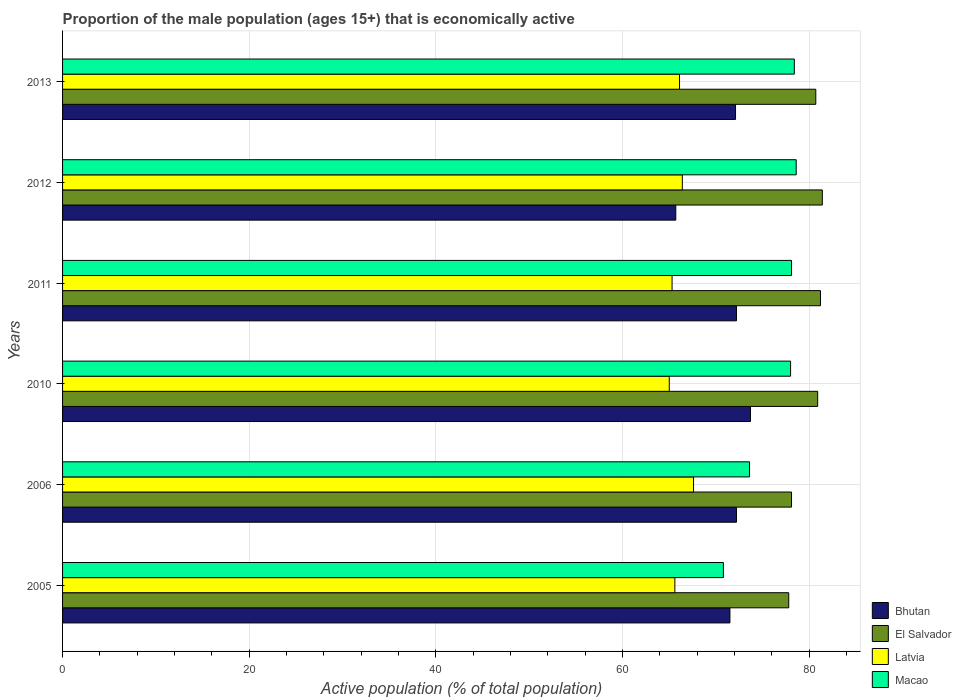How many different coloured bars are there?
Your answer should be very brief. 4. How many bars are there on the 2nd tick from the top?
Give a very brief answer. 4. How many bars are there on the 4th tick from the bottom?
Ensure brevity in your answer.  4. What is the label of the 6th group of bars from the top?
Give a very brief answer. 2005. What is the proportion of the male population that is economically active in Macao in 2012?
Your response must be concise. 78.6. Across all years, what is the maximum proportion of the male population that is economically active in Bhutan?
Provide a succinct answer. 73.7. Across all years, what is the minimum proportion of the male population that is economically active in Latvia?
Ensure brevity in your answer.  65. What is the total proportion of the male population that is economically active in Bhutan in the graph?
Ensure brevity in your answer.  427.4. What is the difference between the proportion of the male population that is economically active in El Salvador in 2010 and that in 2011?
Make the answer very short. -0.3. What is the difference between the proportion of the male population that is economically active in Latvia in 2010 and the proportion of the male population that is economically active in Macao in 2013?
Offer a terse response. -13.4. What is the average proportion of the male population that is economically active in Macao per year?
Make the answer very short. 76.25. In the year 2010, what is the difference between the proportion of the male population that is economically active in Bhutan and proportion of the male population that is economically active in Latvia?
Your answer should be very brief. 8.7. In how many years, is the proportion of the male population that is economically active in El Salvador greater than 24 %?
Make the answer very short. 6. What is the ratio of the proportion of the male population that is economically active in Macao in 2005 to that in 2011?
Your answer should be very brief. 0.91. Is the difference between the proportion of the male population that is economically active in Bhutan in 2006 and 2012 greater than the difference between the proportion of the male population that is economically active in Latvia in 2006 and 2012?
Your answer should be very brief. Yes. What is the difference between the highest and the second highest proportion of the male population that is economically active in Macao?
Ensure brevity in your answer.  0.2. What is the difference between the highest and the lowest proportion of the male population that is economically active in El Salvador?
Make the answer very short. 3.6. Is it the case that in every year, the sum of the proportion of the male population that is economically active in El Salvador and proportion of the male population that is economically active in Latvia is greater than the sum of proportion of the male population that is economically active in Macao and proportion of the male population that is economically active in Bhutan?
Your answer should be very brief. Yes. What does the 1st bar from the top in 2010 represents?
Provide a short and direct response. Macao. What does the 1st bar from the bottom in 2006 represents?
Keep it short and to the point. Bhutan. Are all the bars in the graph horizontal?
Provide a succinct answer. Yes. What is the difference between two consecutive major ticks on the X-axis?
Your answer should be very brief. 20. Are the values on the major ticks of X-axis written in scientific E-notation?
Your answer should be very brief. No. Does the graph contain any zero values?
Offer a very short reply. No. How are the legend labels stacked?
Your answer should be compact. Vertical. What is the title of the graph?
Ensure brevity in your answer.  Proportion of the male population (ages 15+) that is economically active. Does "Isle of Man" appear as one of the legend labels in the graph?
Provide a succinct answer. No. What is the label or title of the X-axis?
Keep it short and to the point. Active population (% of total population). What is the label or title of the Y-axis?
Give a very brief answer. Years. What is the Active population (% of total population) in Bhutan in 2005?
Ensure brevity in your answer.  71.5. What is the Active population (% of total population) of El Salvador in 2005?
Make the answer very short. 77.8. What is the Active population (% of total population) of Latvia in 2005?
Offer a terse response. 65.6. What is the Active population (% of total population) of Macao in 2005?
Offer a terse response. 70.8. What is the Active population (% of total population) of Bhutan in 2006?
Offer a terse response. 72.2. What is the Active population (% of total population) of El Salvador in 2006?
Offer a very short reply. 78.1. What is the Active population (% of total population) of Latvia in 2006?
Offer a terse response. 67.6. What is the Active population (% of total population) in Macao in 2006?
Give a very brief answer. 73.6. What is the Active population (% of total population) of Bhutan in 2010?
Provide a succinct answer. 73.7. What is the Active population (% of total population) in El Salvador in 2010?
Give a very brief answer. 80.9. What is the Active population (% of total population) of Latvia in 2010?
Your answer should be very brief. 65. What is the Active population (% of total population) of Bhutan in 2011?
Give a very brief answer. 72.2. What is the Active population (% of total population) of El Salvador in 2011?
Your answer should be very brief. 81.2. What is the Active population (% of total population) of Latvia in 2011?
Keep it short and to the point. 65.3. What is the Active population (% of total population) in Macao in 2011?
Provide a short and direct response. 78.1. What is the Active population (% of total population) of Bhutan in 2012?
Offer a terse response. 65.7. What is the Active population (% of total population) in El Salvador in 2012?
Provide a short and direct response. 81.4. What is the Active population (% of total population) in Latvia in 2012?
Your answer should be compact. 66.4. What is the Active population (% of total population) in Macao in 2012?
Provide a short and direct response. 78.6. What is the Active population (% of total population) in Bhutan in 2013?
Keep it short and to the point. 72.1. What is the Active population (% of total population) of El Salvador in 2013?
Provide a short and direct response. 80.7. What is the Active population (% of total population) of Latvia in 2013?
Keep it short and to the point. 66.1. What is the Active population (% of total population) of Macao in 2013?
Give a very brief answer. 78.4. Across all years, what is the maximum Active population (% of total population) in Bhutan?
Keep it short and to the point. 73.7. Across all years, what is the maximum Active population (% of total population) of El Salvador?
Provide a short and direct response. 81.4. Across all years, what is the maximum Active population (% of total population) of Latvia?
Your answer should be compact. 67.6. Across all years, what is the maximum Active population (% of total population) of Macao?
Make the answer very short. 78.6. Across all years, what is the minimum Active population (% of total population) in Bhutan?
Offer a very short reply. 65.7. Across all years, what is the minimum Active population (% of total population) in El Salvador?
Offer a terse response. 77.8. Across all years, what is the minimum Active population (% of total population) in Latvia?
Provide a succinct answer. 65. Across all years, what is the minimum Active population (% of total population) of Macao?
Make the answer very short. 70.8. What is the total Active population (% of total population) in Bhutan in the graph?
Keep it short and to the point. 427.4. What is the total Active population (% of total population) of El Salvador in the graph?
Provide a short and direct response. 480.1. What is the total Active population (% of total population) of Latvia in the graph?
Your answer should be very brief. 396. What is the total Active population (% of total population) in Macao in the graph?
Provide a succinct answer. 457.5. What is the difference between the Active population (% of total population) of Latvia in 2005 and that in 2011?
Offer a very short reply. 0.3. What is the difference between the Active population (% of total population) of Macao in 2005 and that in 2011?
Your answer should be very brief. -7.3. What is the difference between the Active population (% of total population) in Bhutan in 2005 and that in 2013?
Offer a very short reply. -0.6. What is the difference between the Active population (% of total population) in Macao in 2005 and that in 2013?
Your response must be concise. -7.6. What is the difference between the Active population (% of total population) in El Salvador in 2006 and that in 2010?
Your response must be concise. -2.8. What is the difference between the Active population (% of total population) in Latvia in 2006 and that in 2010?
Give a very brief answer. 2.6. What is the difference between the Active population (% of total population) in Macao in 2006 and that in 2010?
Provide a short and direct response. -4.4. What is the difference between the Active population (% of total population) in Latvia in 2006 and that in 2011?
Provide a short and direct response. 2.3. What is the difference between the Active population (% of total population) in Bhutan in 2006 and that in 2012?
Your answer should be compact. 6.5. What is the difference between the Active population (% of total population) in El Salvador in 2006 and that in 2012?
Provide a succinct answer. -3.3. What is the difference between the Active population (% of total population) in Latvia in 2006 and that in 2012?
Keep it short and to the point. 1.2. What is the difference between the Active population (% of total population) in Bhutan in 2006 and that in 2013?
Offer a terse response. 0.1. What is the difference between the Active population (% of total population) in El Salvador in 2006 and that in 2013?
Your answer should be very brief. -2.6. What is the difference between the Active population (% of total population) in Latvia in 2006 and that in 2013?
Keep it short and to the point. 1.5. What is the difference between the Active population (% of total population) of Macao in 2006 and that in 2013?
Provide a succinct answer. -4.8. What is the difference between the Active population (% of total population) in Bhutan in 2010 and that in 2011?
Provide a short and direct response. 1.5. What is the difference between the Active population (% of total population) in El Salvador in 2010 and that in 2011?
Give a very brief answer. -0.3. What is the difference between the Active population (% of total population) in Latvia in 2010 and that in 2011?
Keep it short and to the point. -0.3. What is the difference between the Active population (% of total population) in Bhutan in 2010 and that in 2012?
Make the answer very short. 8. What is the difference between the Active population (% of total population) in El Salvador in 2010 and that in 2012?
Make the answer very short. -0.5. What is the difference between the Active population (% of total population) of Latvia in 2010 and that in 2012?
Your response must be concise. -1.4. What is the difference between the Active population (% of total population) of Bhutan in 2011 and that in 2012?
Offer a terse response. 6.5. What is the difference between the Active population (% of total population) of El Salvador in 2011 and that in 2012?
Offer a very short reply. -0.2. What is the difference between the Active population (% of total population) of Latvia in 2011 and that in 2012?
Ensure brevity in your answer.  -1.1. What is the difference between the Active population (% of total population) in Macao in 2011 and that in 2012?
Ensure brevity in your answer.  -0.5. What is the difference between the Active population (% of total population) in Latvia in 2011 and that in 2013?
Keep it short and to the point. -0.8. What is the difference between the Active population (% of total population) of Bhutan in 2012 and that in 2013?
Keep it short and to the point. -6.4. What is the difference between the Active population (% of total population) of Macao in 2012 and that in 2013?
Offer a very short reply. 0.2. What is the difference between the Active population (% of total population) in Bhutan in 2005 and the Active population (% of total population) in Latvia in 2010?
Provide a succinct answer. 6.5. What is the difference between the Active population (% of total population) of Bhutan in 2005 and the Active population (% of total population) of Macao in 2011?
Keep it short and to the point. -6.6. What is the difference between the Active population (% of total population) in El Salvador in 2005 and the Active population (% of total population) in Latvia in 2011?
Offer a terse response. 12.5. What is the difference between the Active population (% of total population) in Latvia in 2005 and the Active population (% of total population) in Macao in 2011?
Your answer should be very brief. -12.5. What is the difference between the Active population (% of total population) in Bhutan in 2005 and the Active population (% of total population) in Latvia in 2012?
Ensure brevity in your answer.  5.1. What is the difference between the Active population (% of total population) in El Salvador in 2005 and the Active population (% of total population) in Latvia in 2012?
Provide a succinct answer. 11.4. What is the difference between the Active population (% of total population) in El Salvador in 2005 and the Active population (% of total population) in Macao in 2012?
Provide a succinct answer. -0.8. What is the difference between the Active population (% of total population) in Latvia in 2005 and the Active population (% of total population) in Macao in 2012?
Provide a short and direct response. -13. What is the difference between the Active population (% of total population) in Bhutan in 2005 and the Active population (% of total population) in El Salvador in 2013?
Your response must be concise. -9.2. What is the difference between the Active population (% of total population) of Bhutan in 2005 and the Active population (% of total population) of Latvia in 2013?
Provide a succinct answer. 5.4. What is the difference between the Active population (% of total population) in Bhutan in 2006 and the Active population (% of total population) in El Salvador in 2010?
Make the answer very short. -8.7. What is the difference between the Active population (% of total population) in Bhutan in 2006 and the Active population (% of total population) in Latvia in 2010?
Your answer should be very brief. 7.2. What is the difference between the Active population (% of total population) of Bhutan in 2006 and the Active population (% of total population) of Macao in 2010?
Your answer should be compact. -5.8. What is the difference between the Active population (% of total population) of El Salvador in 2006 and the Active population (% of total population) of Latvia in 2011?
Provide a short and direct response. 12.8. What is the difference between the Active population (% of total population) of El Salvador in 2006 and the Active population (% of total population) of Macao in 2011?
Offer a terse response. 0. What is the difference between the Active population (% of total population) in Latvia in 2006 and the Active population (% of total population) in Macao in 2011?
Offer a very short reply. -10.5. What is the difference between the Active population (% of total population) in El Salvador in 2006 and the Active population (% of total population) in Latvia in 2012?
Make the answer very short. 11.7. What is the difference between the Active population (% of total population) in El Salvador in 2006 and the Active population (% of total population) in Macao in 2012?
Offer a terse response. -0.5. What is the difference between the Active population (% of total population) of Bhutan in 2006 and the Active population (% of total population) of Latvia in 2013?
Make the answer very short. 6.1. What is the difference between the Active population (% of total population) of Bhutan in 2006 and the Active population (% of total population) of Macao in 2013?
Keep it short and to the point. -6.2. What is the difference between the Active population (% of total population) of El Salvador in 2006 and the Active population (% of total population) of Latvia in 2013?
Provide a succinct answer. 12. What is the difference between the Active population (% of total population) of Latvia in 2006 and the Active population (% of total population) of Macao in 2013?
Keep it short and to the point. -10.8. What is the difference between the Active population (% of total population) in Bhutan in 2010 and the Active population (% of total population) in El Salvador in 2011?
Keep it short and to the point. -7.5. What is the difference between the Active population (% of total population) of Bhutan in 2010 and the Active population (% of total population) of Latvia in 2011?
Offer a terse response. 8.4. What is the difference between the Active population (% of total population) in El Salvador in 2010 and the Active population (% of total population) in Macao in 2011?
Your response must be concise. 2.8. What is the difference between the Active population (% of total population) in Latvia in 2010 and the Active population (% of total population) in Macao in 2011?
Your answer should be very brief. -13.1. What is the difference between the Active population (% of total population) of Bhutan in 2010 and the Active population (% of total population) of Latvia in 2012?
Your answer should be very brief. 7.3. What is the difference between the Active population (% of total population) of Latvia in 2010 and the Active population (% of total population) of Macao in 2012?
Keep it short and to the point. -13.6. What is the difference between the Active population (% of total population) in Bhutan in 2010 and the Active population (% of total population) in El Salvador in 2013?
Keep it short and to the point. -7. What is the difference between the Active population (% of total population) in Bhutan in 2010 and the Active population (% of total population) in Latvia in 2013?
Provide a short and direct response. 7.6. What is the difference between the Active population (% of total population) of El Salvador in 2010 and the Active population (% of total population) of Latvia in 2013?
Your answer should be compact. 14.8. What is the difference between the Active population (% of total population) in El Salvador in 2010 and the Active population (% of total population) in Macao in 2013?
Offer a terse response. 2.5. What is the difference between the Active population (% of total population) of Latvia in 2010 and the Active population (% of total population) of Macao in 2013?
Give a very brief answer. -13.4. What is the difference between the Active population (% of total population) of Bhutan in 2011 and the Active population (% of total population) of Latvia in 2012?
Make the answer very short. 5.8. What is the difference between the Active population (% of total population) of El Salvador in 2011 and the Active population (% of total population) of Macao in 2012?
Your response must be concise. 2.6. What is the difference between the Active population (% of total population) of Bhutan in 2011 and the Active population (% of total population) of El Salvador in 2013?
Offer a terse response. -8.5. What is the difference between the Active population (% of total population) in Bhutan in 2011 and the Active population (% of total population) in Latvia in 2013?
Your response must be concise. 6.1. What is the difference between the Active population (% of total population) of Bhutan in 2011 and the Active population (% of total population) of Macao in 2013?
Provide a succinct answer. -6.2. What is the difference between the Active population (% of total population) of Bhutan in 2012 and the Active population (% of total population) of Macao in 2013?
Provide a succinct answer. -12.7. What is the average Active population (% of total population) in Bhutan per year?
Your answer should be very brief. 71.23. What is the average Active population (% of total population) in El Salvador per year?
Give a very brief answer. 80.02. What is the average Active population (% of total population) in Macao per year?
Your response must be concise. 76.25. In the year 2005, what is the difference between the Active population (% of total population) of Bhutan and Active population (% of total population) of Latvia?
Provide a succinct answer. 5.9. In the year 2005, what is the difference between the Active population (% of total population) of Bhutan and Active population (% of total population) of Macao?
Provide a succinct answer. 0.7. In the year 2006, what is the difference between the Active population (% of total population) in Bhutan and Active population (% of total population) in Latvia?
Your response must be concise. 4.6. In the year 2006, what is the difference between the Active population (% of total population) in El Salvador and Active population (% of total population) in Macao?
Your answer should be very brief. 4.5. In the year 2010, what is the difference between the Active population (% of total population) in Bhutan and Active population (% of total population) in Latvia?
Your answer should be compact. 8.7. In the year 2010, what is the difference between the Active population (% of total population) in El Salvador and Active population (% of total population) in Macao?
Provide a short and direct response. 2.9. In the year 2010, what is the difference between the Active population (% of total population) of Latvia and Active population (% of total population) of Macao?
Offer a very short reply. -13. In the year 2011, what is the difference between the Active population (% of total population) of Bhutan and Active population (% of total population) of Latvia?
Keep it short and to the point. 6.9. In the year 2011, what is the difference between the Active population (% of total population) of El Salvador and Active population (% of total population) of Macao?
Give a very brief answer. 3.1. In the year 2012, what is the difference between the Active population (% of total population) in Bhutan and Active population (% of total population) in El Salvador?
Keep it short and to the point. -15.7. In the year 2012, what is the difference between the Active population (% of total population) of Bhutan and Active population (% of total population) of Latvia?
Give a very brief answer. -0.7. In the year 2012, what is the difference between the Active population (% of total population) of El Salvador and Active population (% of total population) of Latvia?
Provide a short and direct response. 15. In the year 2012, what is the difference between the Active population (% of total population) in Latvia and Active population (% of total population) in Macao?
Offer a terse response. -12.2. In the year 2013, what is the difference between the Active population (% of total population) in Bhutan and Active population (% of total population) in Latvia?
Your answer should be compact. 6. In the year 2013, what is the difference between the Active population (% of total population) in Bhutan and Active population (% of total population) in Macao?
Provide a short and direct response. -6.3. In the year 2013, what is the difference between the Active population (% of total population) of El Salvador and Active population (% of total population) of Latvia?
Provide a short and direct response. 14.6. In the year 2013, what is the difference between the Active population (% of total population) in El Salvador and Active population (% of total population) in Macao?
Your answer should be compact. 2.3. What is the ratio of the Active population (% of total population) of Bhutan in 2005 to that in 2006?
Provide a succinct answer. 0.99. What is the ratio of the Active population (% of total population) in Latvia in 2005 to that in 2006?
Make the answer very short. 0.97. What is the ratio of the Active population (% of total population) in Bhutan in 2005 to that in 2010?
Provide a succinct answer. 0.97. What is the ratio of the Active population (% of total population) in El Salvador in 2005 to that in 2010?
Provide a short and direct response. 0.96. What is the ratio of the Active population (% of total population) in Latvia in 2005 to that in 2010?
Your answer should be compact. 1.01. What is the ratio of the Active population (% of total population) in Macao in 2005 to that in 2010?
Ensure brevity in your answer.  0.91. What is the ratio of the Active population (% of total population) in Bhutan in 2005 to that in 2011?
Make the answer very short. 0.99. What is the ratio of the Active population (% of total population) of El Salvador in 2005 to that in 2011?
Ensure brevity in your answer.  0.96. What is the ratio of the Active population (% of total population) of Latvia in 2005 to that in 2011?
Give a very brief answer. 1. What is the ratio of the Active population (% of total population) of Macao in 2005 to that in 2011?
Offer a very short reply. 0.91. What is the ratio of the Active population (% of total population) in Bhutan in 2005 to that in 2012?
Make the answer very short. 1.09. What is the ratio of the Active population (% of total population) of El Salvador in 2005 to that in 2012?
Give a very brief answer. 0.96. What is the ratio of the Active population (% of total population) in Macao in 2005 to that in 2012?
Your answer should be very brief. 0.9. What is the ratio of the Active population (% of total population) in Bhutan in 2005 to that in 2013?
Offer a terse response. 0.99. What is the ratio of the Active population (% of total population) in El Salvador in 2005 to that in 2013?
Provide a short and direct response. 0.96. What is the ratio of the Active population (% of total population) of Latvia in 2005 to that in 2013?
Offer a very short reply. 0.99. What is the ratio of the Active population (% of total population) of Macao in 2005 to that in 2013?
Your answer should be compact. 0.9. What is the ratio of the Active population (% of total population) of Bhutan in 2006 to that in 2010?
Your response must be concise. 0.98. What is the ratio of the Active population (% of total population) in El Salvador in 2006 to that in 2010?
Make the answer very short. 0.97. What is the ratio of the Active population (% of total population) of Latvia in 2006 to that in 2010?
Offer a terse response. 1.04. What is the ratio of the Active population (% of total population) in Macao in 2006 to that in 2010?
Ensure brevity in your answer.  0.94. What is the ratio of the Active population (% of total population) of Bhutan in 2006 to that in 2011?
Offer a terse response. 1. What is the ratio of the Active population (% of total population) in El Salvador in 2006 to that in 2011?
Keep it short and to the point. 0.96. What is the ratio of the Active population (% of total population) in Latvia in 2006 to that in 2011?
Your response must be concise. 1.04. What is the ratio of the Active population (% of total population) in Macao in 2006 to that in 2011?
Your response must be concise. 0.94. What is the ratio of the Active population (% of total population) of Bhutan in 2006 to that in 2012?
Provide a short and direct response. 1.1. What is the ratio of the Active population (% of total population) in El Salvador in 2006 to that in 2012?
Provide a short and direct response. 0.96. What is the ratio of the Active population (% of total population) in Latvia in 2006 to that in 2012?
Provide a short and direct response. 1.02. What is the ratio of the Active population (% of total population) of Macao in 2006 to that in 2012?
Give a very brief answer. 0.94. What is the ratio of the Active population (% of total population) of Bhutan in 2006 to that in 2013?
Your answer should be very brief. 1. What is the ratio of the Active population (% of total population) in El Salvador in 2006 to that in 2013?
Provide a short and direct response. 0.97. What is the ratio of the Active population (% of total population) of Latvia in 2006 to that in 2013?
Keep it short and to the point. 1.02. What is the ratio of the Active population (% of total population) in Macao in 2006 to that in 2013?
Your answer should be compact. 0.94. What is the ratio of the Active population (% of total population) in Bhutan in 2010 to that in 2011?
Your response must be concise. 1.02. What is the ratio of the Active population (% of total population) in El Salvador in 2010 to that in 2011?
Make the answer very short. 1. What is the ratio of the Active population (% of total population) of Latvia in 2010 to that in 2011?
Provide a short and direct response. 1. What is the ratio of the Active population (% of total population) in Bhutan in 2010 to that in 2012?
Provide a short and direct response. 1.12. What is the ratio of the Active population (% of total population) in Latvia in 2010 to that in 2012?
Give a very brief answer. 0.98. What is the ratio of the Active population (% of total population) of Bhutan in 2010 to that in 2013?
Offer a terse response. 1.02. What is the ratio of the Active population (% of total population) in Latvia in 2010 to that in 2013?
Offer a terse response. 0.98. What is the ratio of the Active population (% of total population) of Macao in 2010 to that in 2013?
Make the answer very short. 0.99. What is the ratio of the Active population (% of total population) in Bhutan in 2011 to that in 2012?
Offer a very short reply. 1.1. What is the ratio of the Active population (% of total population) of Latvia in 2011 to that in 2012?
Your answer should be very brief. 0.98. What is the ratio of the Active population (% of total population) of Latvia in 2011 to that in 2013?
Offer a very short reply. 0.99. What is the ratio of the Active population (% of total population) in Bhutan in 2012 to that in 2013?
Provide a short and direct response. 0.91. What is the ratio of the Active population (% of total population) of El Salvador in 2012 to that in 2013?
Keep it short and to the point. 1.01. What is the ratio of the Active population (% of total population) in Latvia in 2012 to that in 2013?
Provide a short and direct response. 1. What is the difference between the highest and the second highest Active population (% of total population) in Bhutan?
Provide a succinct answer. 1.5. What is the difference between the highest and the second highest Active population (% of total population) of El Salvador?
Your answer should be compact. 0.2. What is the difference between the highest and the second highest Active population (% of total population) of Macao?
Provide a short and direct response. 0.2. What is the difference between the highest and the lowest Active population (% of total population) of Bhutan?
Ensure brevity in your answer.  8. What is the difference between the highest and the lowest Active population (% of total population) of El Salvador?
Your response must be concise. 3.6. What is the difference between the highest and the lowest Active population (% of total population) of Latvia?
Keep it short and to the point. 2.6. 